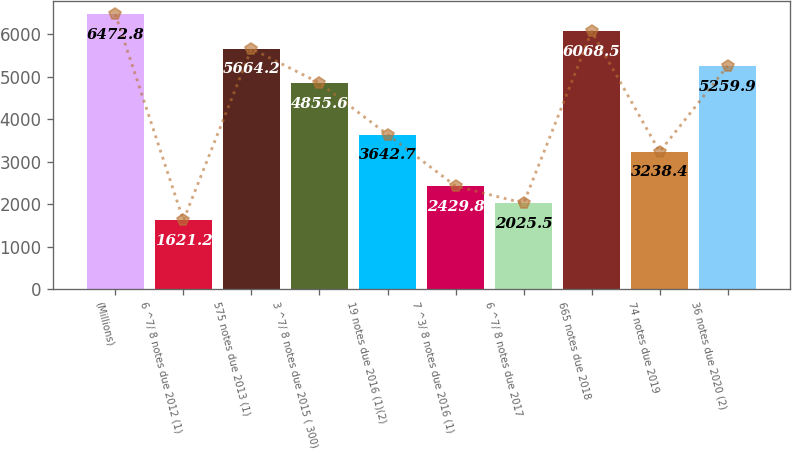Convert chart. <chart><loc_0><loc_0><loc_500><loc_500><bar_chart><fcel>(Millions)<fcel>6 ^7/ 8 notes due 2012 (1)<fcel>575 notes due 2013 (1)<fcel>3 ^7/ 8 notes due 2015 ( 300)<fcel>19 notes due 2016 (1)(2)<fcel>7 ^3/ 8 notes due 2016 (1)<fcel>6 ^7/ 8 notes due 2017<fcel>665 notes due 2018<fcel>74 notes due 2019<fcel>36 notes due 2020 (2)<nl><fcel>6472.8<fcel>1621.2<fcel>5664.2<fcel>4855.6<fcel>3642.7<fcel>2429.8<fcel>2025.5<fcel>6068.5<fcel>3238.4<fcel>5259.9<nl></chart> 